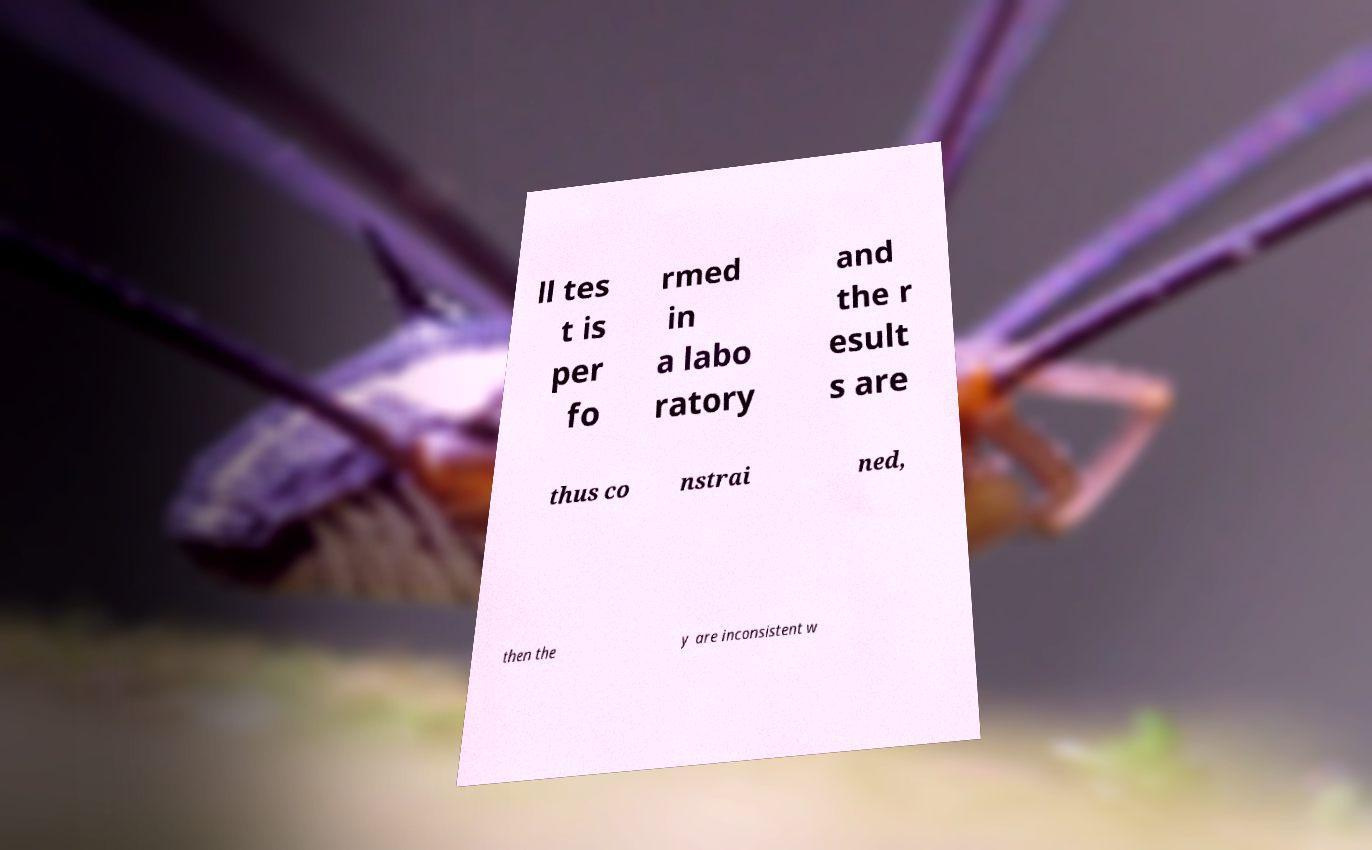What messages or text are displayed in this image? I need them in a readable, typed format. ll tes t is per fo rmed in a labo ratory and the r esult s are thus co nstrai ned, then the y are inconsistent w 